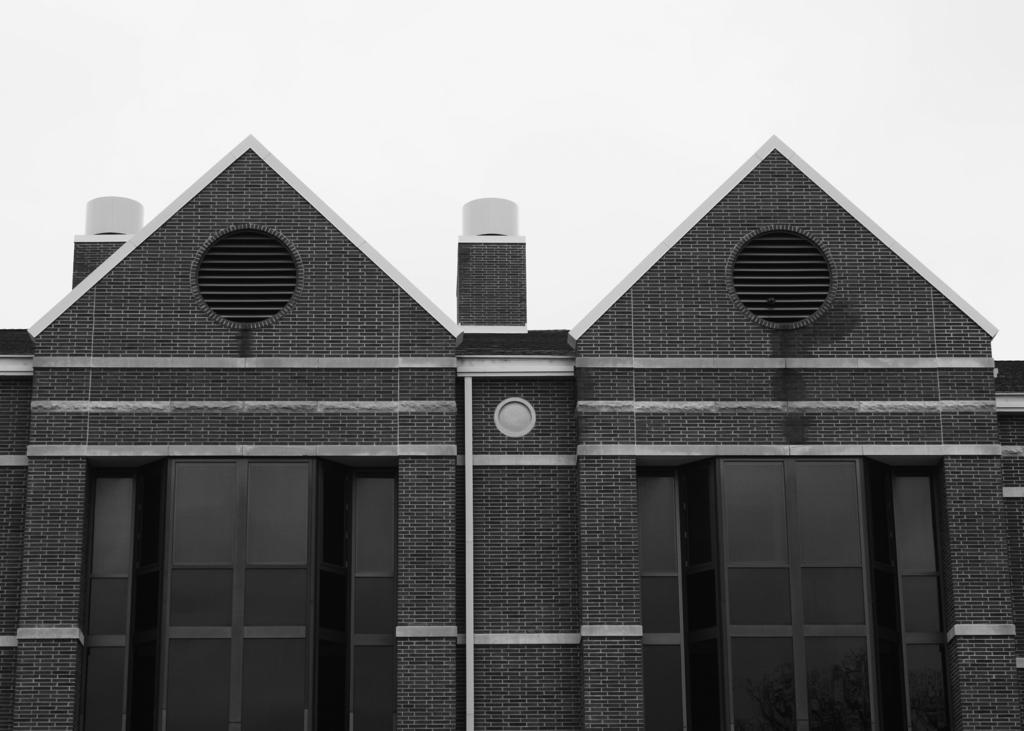What is the main subject of the image? The main subject of the image is a building. How many windows are visible on the building? The building has 2 windows. What color is the background of the image? The background of the image is white. Is the image in color or black and white? The image is in black and white. Can you tell me how many goats are standing next to the building in the image? There are no goats present in the image; it only features a building with 2 windows. How does the image show an increase in the number of windows compared to the previous version? The image does not show any previous version or comparison, and there is no mention of an increase in the number of windows. 